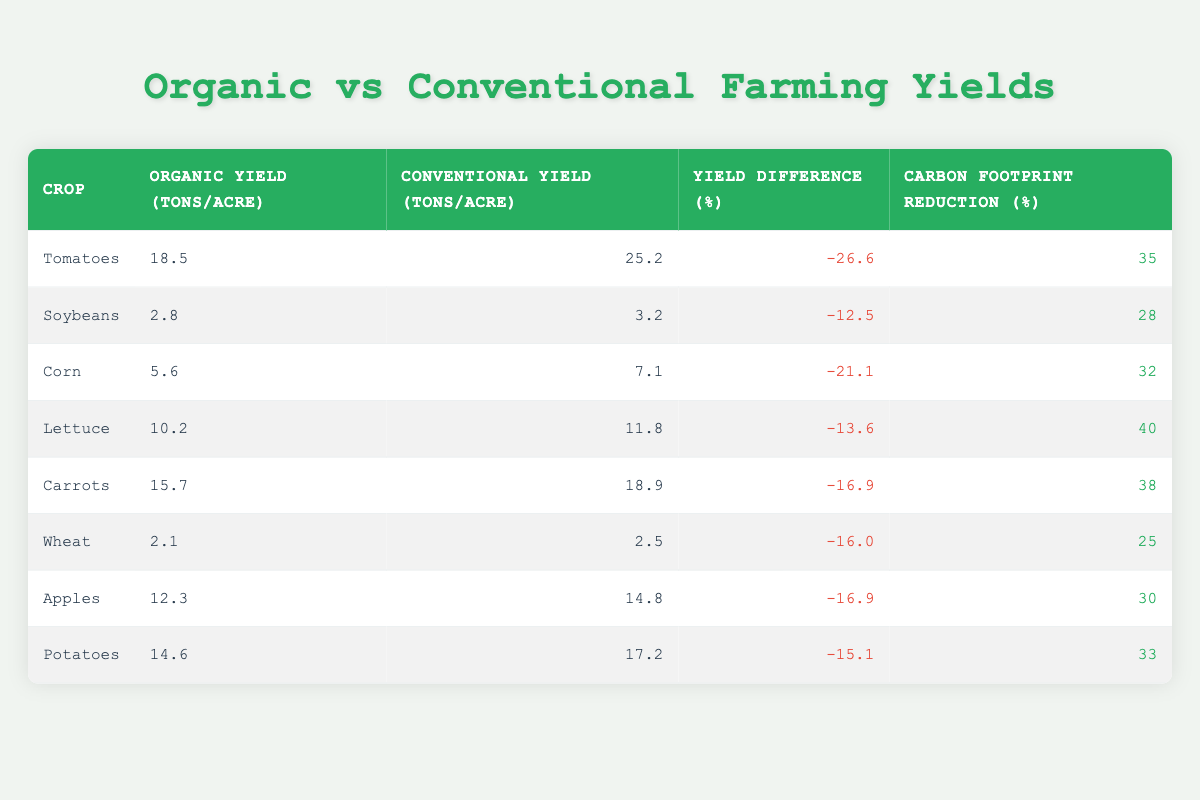What is the yield difference for potatoes? The yield difference for potatoes is found in the "Yield Difference (%)" column for potatoes, which is listed as -15.1.
Answer: -15.1 Which crop has the highest carbon footprint reduction percentage? Looking at the "Carbon Footprint Reduction (%)" column, lettuce has the highest percentage at 40.
Answer: 40 What is the average organic yield across all crops? First, I sum the organic yields: (18.5 + 2.8 + 5.6 + 10.2 + 15.7 + 2.1 + 12.3 + 14.6) = 77.8. Since there are 8 crops, I divide this total by 8: 77.8 / 8 = 9.725.
Answer: 9.725 Do all crops show a decline in organic yield compared to conventional yield? By checking the "Yield Difference (%)" column for each crop, all values are negative, indicating a decline in organic yield compared to conventional yield.
Answer: Yes What is the difference in carbon footprint reduction between corn and soybeans? The carbon footprint reduction for corn is 32%, and for soybeans, it is 28%. To find the difference, I subtract: 32 - 28 = 4.
Answer: 4 How many crops have a yield difference lower than -20%? I review the "Yield Difference (%)" column and find that tomatoes (-26.6), corn (-21.1), and carrots (-16.9) all have yield differences lower than -20%. This results in a total of 3 crops.
Answer: 3 Which crop has the lowest organic yield? Among the "Organic Yield (tons/acre)" column, wheat with a yield of 2.1 is the lowest.
Answer: 2.1 What is the total carbon footprint reduction percentage for all crops combined? Since the carbon footprint reduction percentage is not an additive value, this question is ill-defined. Instead, we can look for individual percentages, but summing them does not yield a collective total as they reflect different dimensions.
Answer: Not applicable 